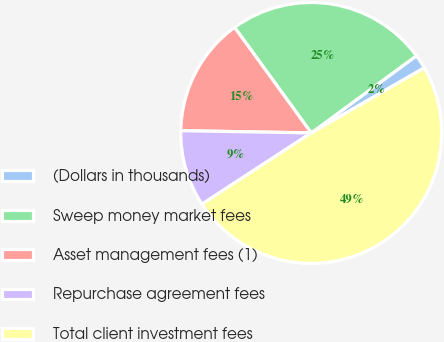Convert chart. <chart><loc_0><loc_0><loc_500><loc_500><pie_chart><fcel>(Dollars in thousands)<fcel>Sweep money market fees<fcel>Asset management fees (1)<fcel>Repurchase agreement fees<fcel>Total client investment fees<nl><fcel>1.76%<fcel>24.92%<fcel>14.73%<fcel>9.47%<fcel>49.12%<nl></chart> 